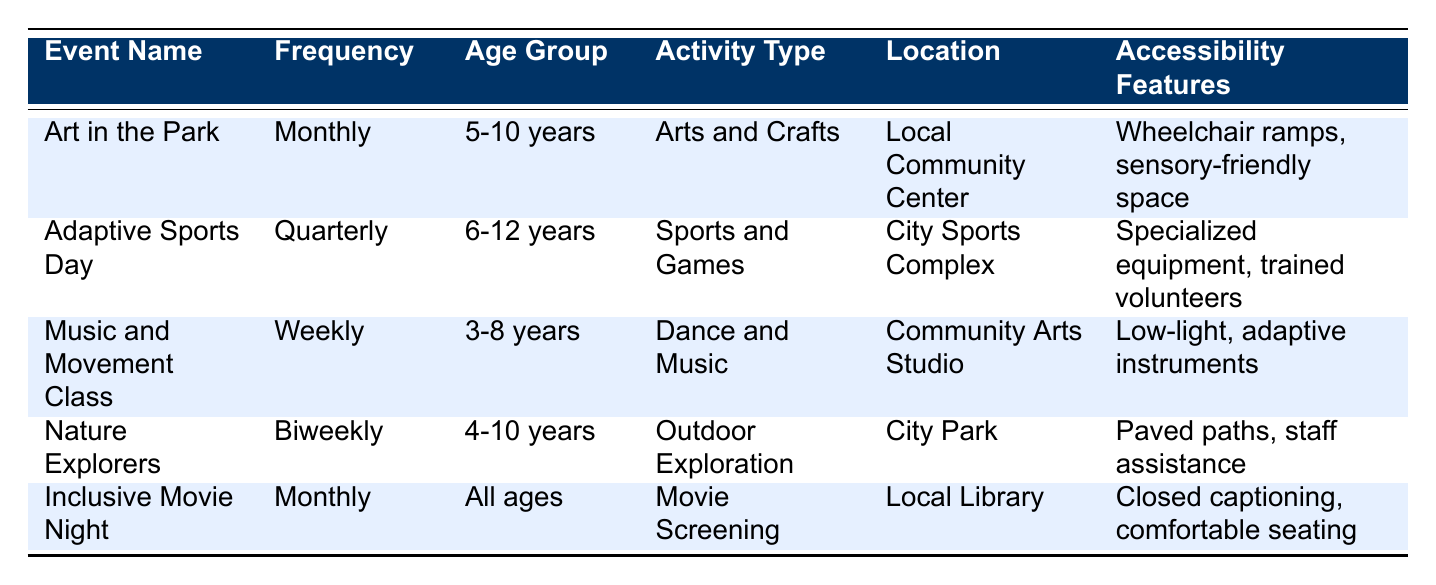What event has the highest frequency of participation? The table lists four different frequencies of participation: Monthly, Quarterly, Weekly, and Biweekly. Among these, the frequency that appears most often is Monthly, with two events: "Art in the Park" and "Inclusive Movie Night."
Answer: Monthly What age group is eligible for the "Nature Explorers" event? The table shows that the "Nature Explorers" event is for the age group "4-10 years," as listed in the age group column next to the event name.
Answer: 4-10 years Is the "Music and Movement Class" held weekly? Yes, according to the table, the frequency of participation for the "Music and Movement Class" is listed as Weekly.
Answer: Yes How many events occur monthly? The table indicates that there are two events with a frequency of Monthly: "Art in the Park" and "Inclusive Movie Night." Therefore, the total count of monthly events is 2.
Answer: 2 Which event takes place at the City Sports Complex? Looking at the location column in the table, "Adaptive Sports Day" is the only event listed that takes place at the City Sports Complex.
Answer: Adaptive Sports Day What is the frequency of the "Inclusive Movie Night"? The frequency associated with the "Inclusive Movie Night" is listed as Monthly, which can be directly found in the frequency column next to that event.
Answer: Monthly How many events are designed for ages 3 to 8? There are two events for the age group 3-8 years: "Music and Movement Class" and "Art in the Park." So, counting the applicable events gives a total of 2.
Answer: 2 Do any events have sensory-friendly features? Yes, both "Art in the Park" and "Music and Movement Class" are noted to have sensory-friendly features such as a sensory-friendly space and low-light conditions, respectively.
Answer: Yes Which event has a biweekly frequency of participation? The "Nature Explorers" event is identified in the table as the event that has a Biweekly frequency of participation.
Answer: Nature Explorers 